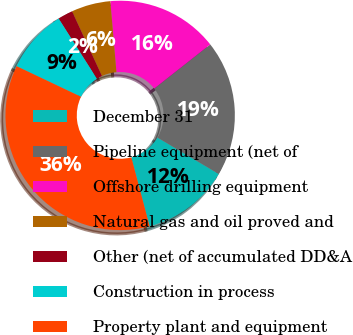Convert chart to OTSL. <chart><loc_0><loc_0><loc_500><loc_500><pie_chart><fcel>December 31<fcel>Pipeline equipment (net of<fcel>Offshore drilling equipment<fcel>Natural gas and oil proved and<fcel>Other (net of accumulated DD&A<fcel>Construction in process<fcel>Property plant and equipment<nl><fcel>12.34%<fcel>19.15%<fcel>15.75%<fcel>5.52%<fcel>2.12%<fcel>8.93%<fcel>36.19%<nl></chart> 